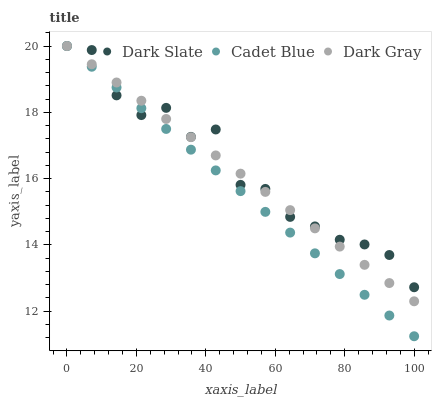Does Cadet Blue have the minimum area under the curve?
Answer yes or no. Yes. Does Dark Slate have the maximum area under the curve?
Answer yes or no. Yes. Does Dark Slate have the minimum area under the curve?
Answer yes or no. No. Does Cadet Blue have the maximum area under the curve?
Answer yes or no. No. Is Dark Gray the smoothest?
Answer yes or no. Yes. Is Dark Slate the roughest?
Answer yes or no. Yes. Is Cadet Blue the smoothest?
Answer yes or no. No. Is Cadet Blue the roughest?
Answer yes or no. No. Does Cadet Blue have the lowest value?
Answer yes or no. Yes. Does Dark Slate have the lowest value?
Answer yes or no. No. Does Cadet Blue have the highest value?
Answer yes or no. Yes. Does Cadet Blue intersect Dark Slate?
Answer yes or no. Yes. Is Cadet Blue less than Dark Slate?
Answer yes or no. No. Is Cadet Blue greater than Dark Slate?
Answer yes or no. No. 